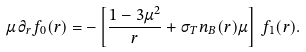Convert formula to latex. <formula><loc_0><loc_0><loc_500><loc_500>\mu \, \partial _ { r } f _ { 0 } ( r ) = - \left [ \frac { 1 - 3 \mu ^ { 2 } } { r } + \sigma _ { T } n _ { B } ( r ) \mu \right ] \, f _ { 1 } ( r ) .</formula> 